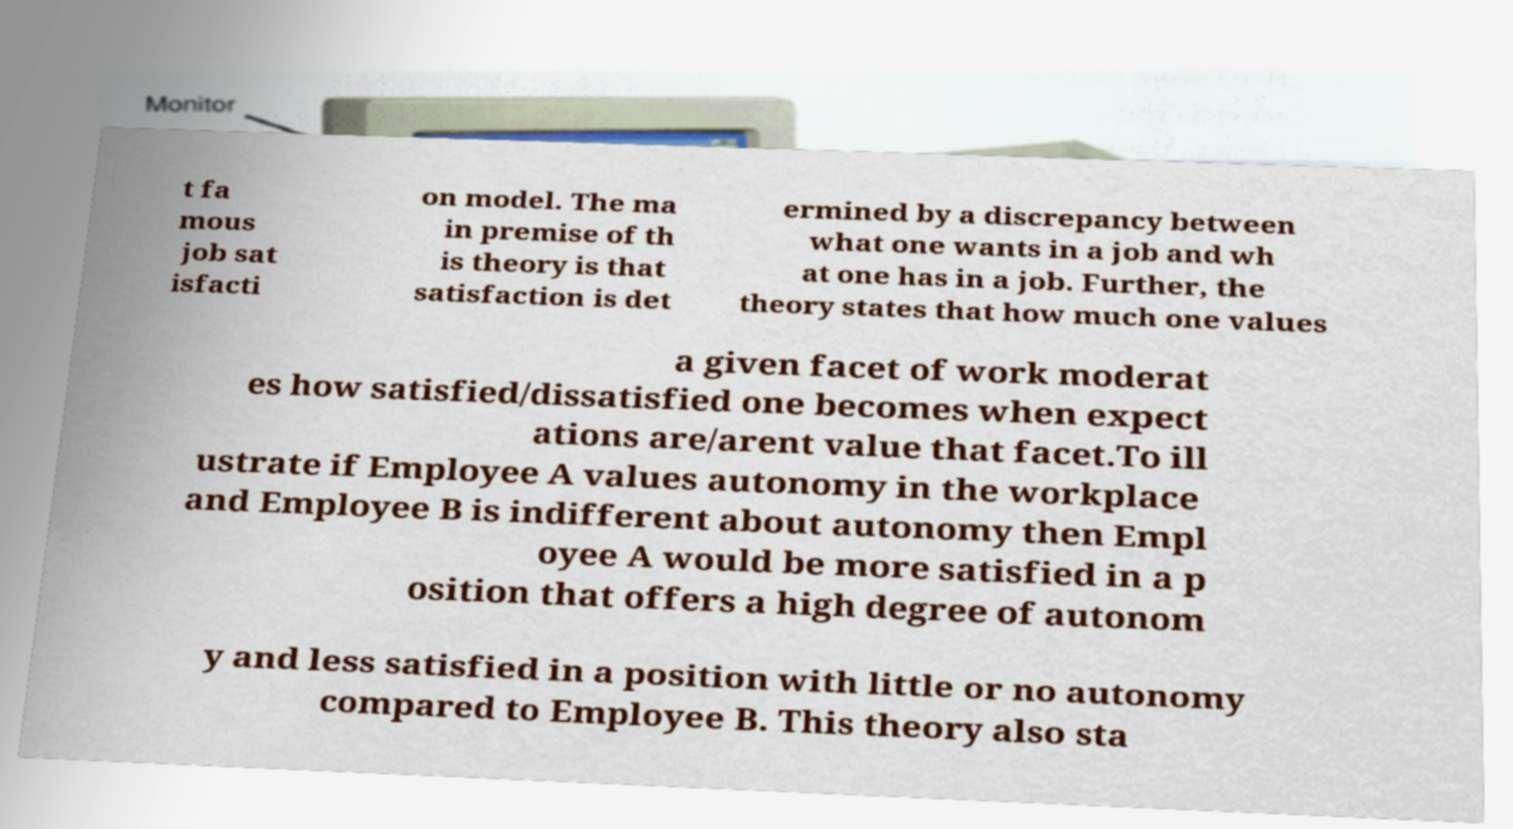What messages or text are displayed in this image? I need them in a readable, typed format. t fa mous job sat isfacti on model. The ma in premise of th is theory is that satisfaction is det ermined by a discrepancy between what one wants in a job and wh at one has in a job. Further, the theory states that how much one values a given facet of work moderat es how satisfied/dissatisfied one becomes when expect ations are/arent value that facet.To ill ustrate if Employee A values autonomy in the workplace and Employee B is indifferent about autonomy then Empl oyee A would be more satisfied in a p osition that offers a high degree of autonom y and less satisfied in a position with little or no autonomy compared to Employee B. This theory also sta 